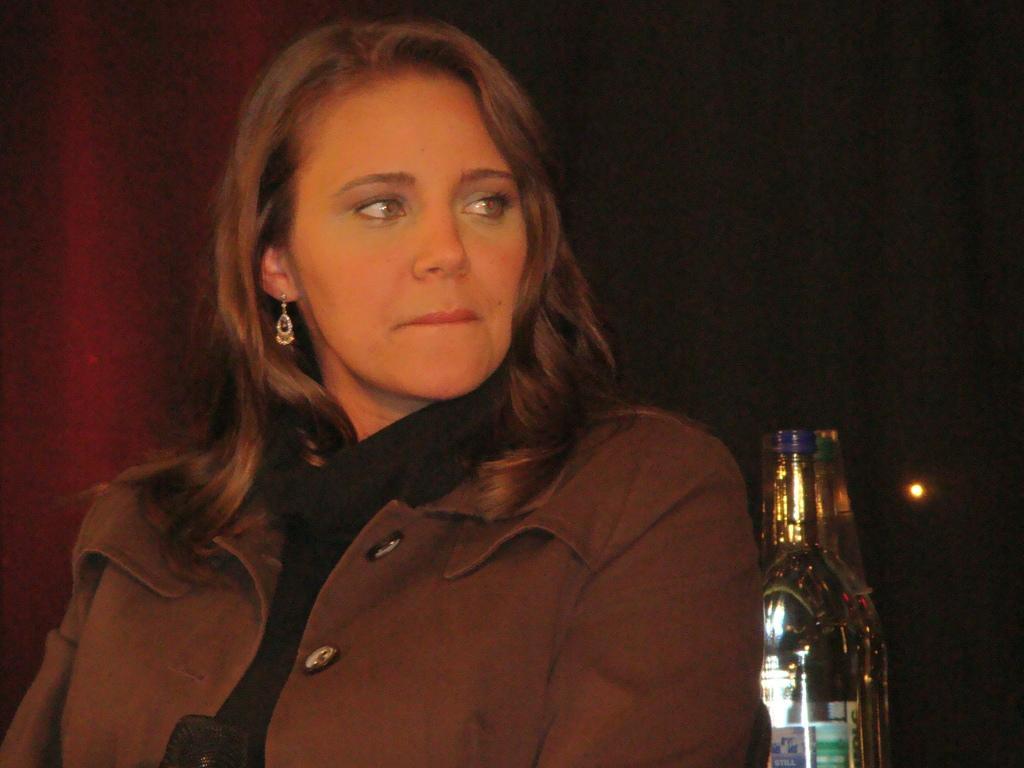Please provide a concise description of this image. In this image we can see a woman wearing brown jacket. In the background we can see a bottle. 